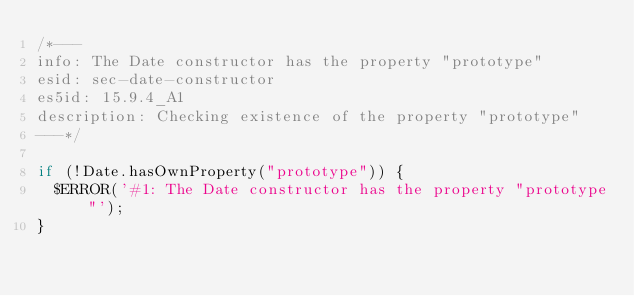<code> <loc_0><loc_0><loc_500><loc_500><_JavaScript_>/*---
info: The Date constructor has the property "prototype"
esid: sec-date-constructor
es5id: 15.9.4_A1
description: Checking existence of the property "prototype"
---*/

if (!Date.hasOwnProperty("prototype")) {
  $ERROR('#1: The Date constructor has the property "prototype"');
}
</code> 